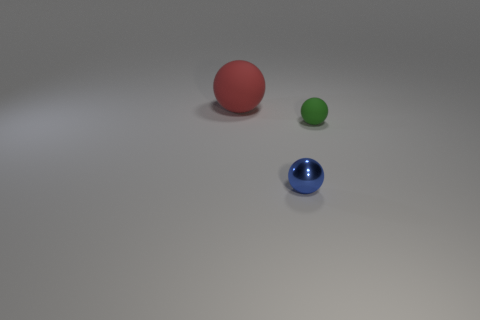Is there any other thing that has the same size as the red matte ball?
Ensure brevity in your answer.  No. What number of metal things are the same color as the big ball?
Give a very brief answer. 0. What color is the large object that is made of the same material as the green sphere?
Your response must be concise. Red. Are there any other red matte spheres that have the same size as the red matte ball?
Your answer should be compact. No. Is the number of things that are left of the small blue metallic object greater than the number of red things right of the red thing?
Your answer should be very brief. Yes. Does the object that is behind the small green rubber sphere have the same material as the small ball that is in front of the small green ball?
Provide a succinct answer. No. There is another matte thing that is the same size as the blue object; what is its shape?
Make the answer very short. Sphere. Is there a big red rubber object of the same shape as the green matte object?
Give a very brief answer. Yes. Are there any things left of the blue metallic sphere?
Your answer should be very brief. Yes. There is a thing that is behind the blue object and to the left of the small green object; what material is it made of?
Offer a very short reply. Rubber. 